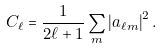<formula> <loc_0><loc_0><loc_500><loc_500>C _ { \ell } = \frac { 1 } { 2 \ell + 1 } \sum _ { m } \left | a _ { \ell m } \right | ^ { 2 } .</formula> 